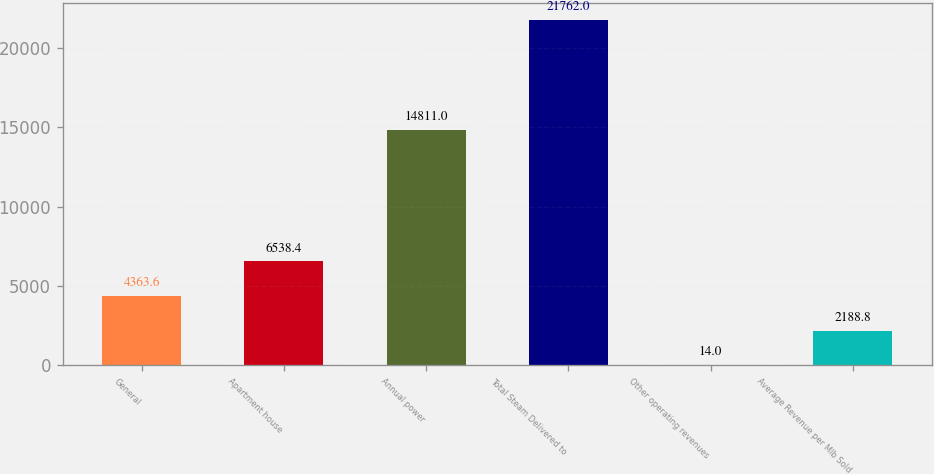<chart> <loc_0><loc_0><loc_500><loc_500><bar_chart><fcel>General<fcel>Apartment house<fcel>Annual power<fcel>Total Steam Delivered to<fcel>Other operating revenues<fcel>Average Revenue per Mlb Sold<nl><fcel>4363.6<fcel>6538.4<fcel>14811<fcel>21762<fcel>14<fcel>2188.8<nl></chart> 